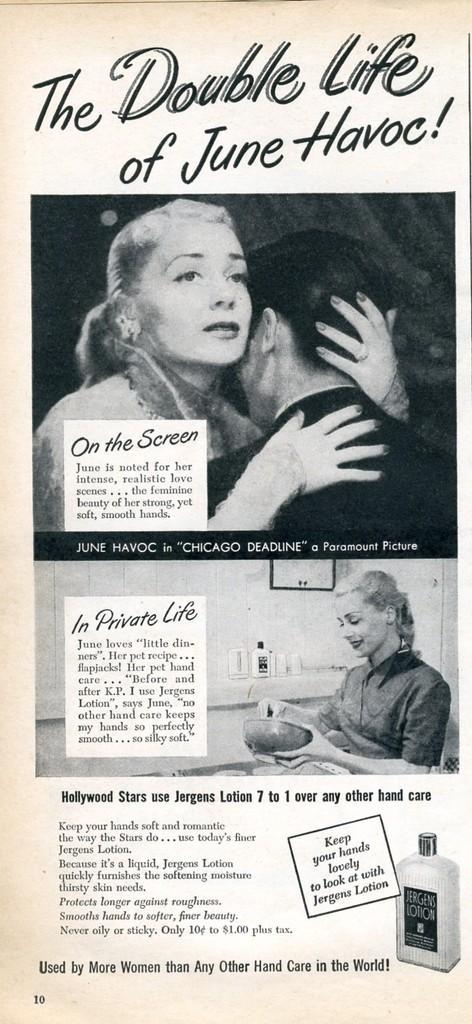Please provide a concise description of this image. In this picture we can see a poster,on which we can see few images and text. 